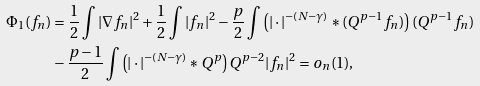Convert formula to latex. <formula><loc_0><loc_0><loc_500><loc_500>\Phi _ { 1 } ( f _ { n } ) & = \frac { 1 } { 2 } \int | \nabla f _ { n } | ^ { 2 } + \frac { 1 } { 2 } \int | f _ { n } | ^ { 2 } - \frac { p } { 2 } \int \left ( | \cdot | ^ { - ( N - \gamma ) } * ( Q ^ { p - 1 } f _ { n } ) \right ) ( Q ^ { p - 1 } f _ { n } ) \\ & - \frac { p - 1 } { 2 } \int \left ( | \cdot | ^ { - ( N - \gamma ) } * Q ^ { p } \right ) Q ^ { p - 2 } | f _ { n } | ^ { 2 } = o _ { n } ( 1 ) ,</formula> 